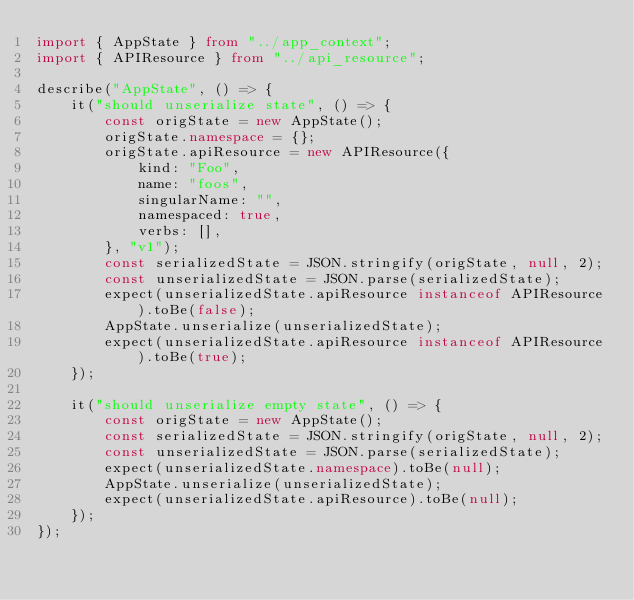Convert code to text. <code><loc_0><loc_0><loc_500><loc_500><_TypeScript_>import { AppState } from "../app_context";
import { APIResource } from "../api_resource";

describe("AppState", () => {
    it("should unserialize state", () => {
        const origState = new AppState();
        origState.namespace = {};
        origState.apiResource = new APIResource({
            kind: "Foo",
            name: "foos",
            singularName: "",
            namespaced: true,
            verbs: [],
        }, "v1");
        const serializedState = JSON.stringify(origState, null, 2);
        const unserializedState = JSON.parse(serializedState);
        expect(unserializedState.apiResource instanceof APIResource).toBe(false);
        AppState.unserialize(unserializedState);
        expect(unserializedState.apiResource instanceof APIResource).toBe(true);
    });

    it("should unserialize empty state", () => {
        const origState = new AppState();
        const serializedState = JSON.stringify(origState, null, 2);
        const unserializedState = JSON.parse(serializedState);
        expect(unserializedState.namespace).toBe(null);
        AppState.unserialize(unserializedState);
        expect(unserializedState.apiResource).toBe(null);
    });
});
</code> 